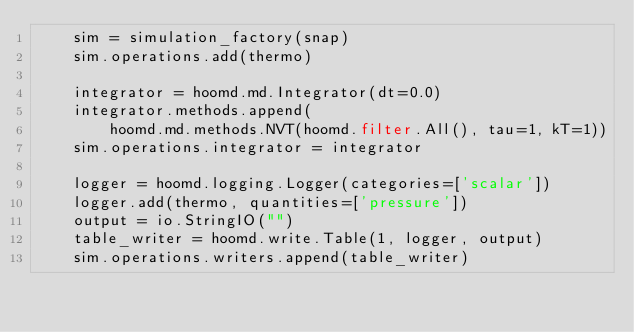Convert code to text. <code><loc_0><loc_0><loc_500><loc_500><_Python_>    sim = simulation_factory(snap)
    sim.operations.add(thermo)

    integrator = hoomd.md.Integrator(dt=0.0)
    integrator.methods.append(
        hoomd.md.methods.NVT(hoomd.filter.All(), tau=1, kT=1))
    sim.operations.integrator = integrator

    logger = hoomd.logging.Logger(categories=['scalar'])
    logger.add(thermo, quantities=['pressure'])
    output = io.StringIO("")
    table_writer = hoomd.write.Table(1, logger, output)
    sim.operations.writers.append(table_writer)
</code> 